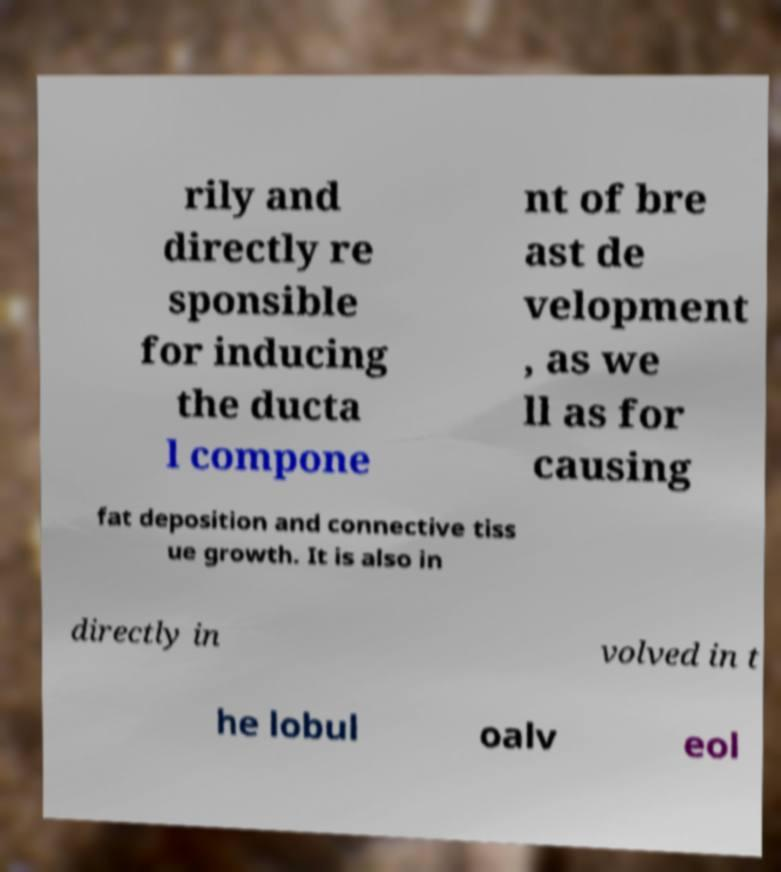Can you read and provide the text displayed in the image?This photo seems to have some interesting text. Can you extract and type it out for me? rily and directly re sponsible for inducing the ducta l compone nt of bre ast de velopment , as we ll as for causing fat deposition and connective tiss ue growth. It is also in directly in volved in t he lobul oalv eol 